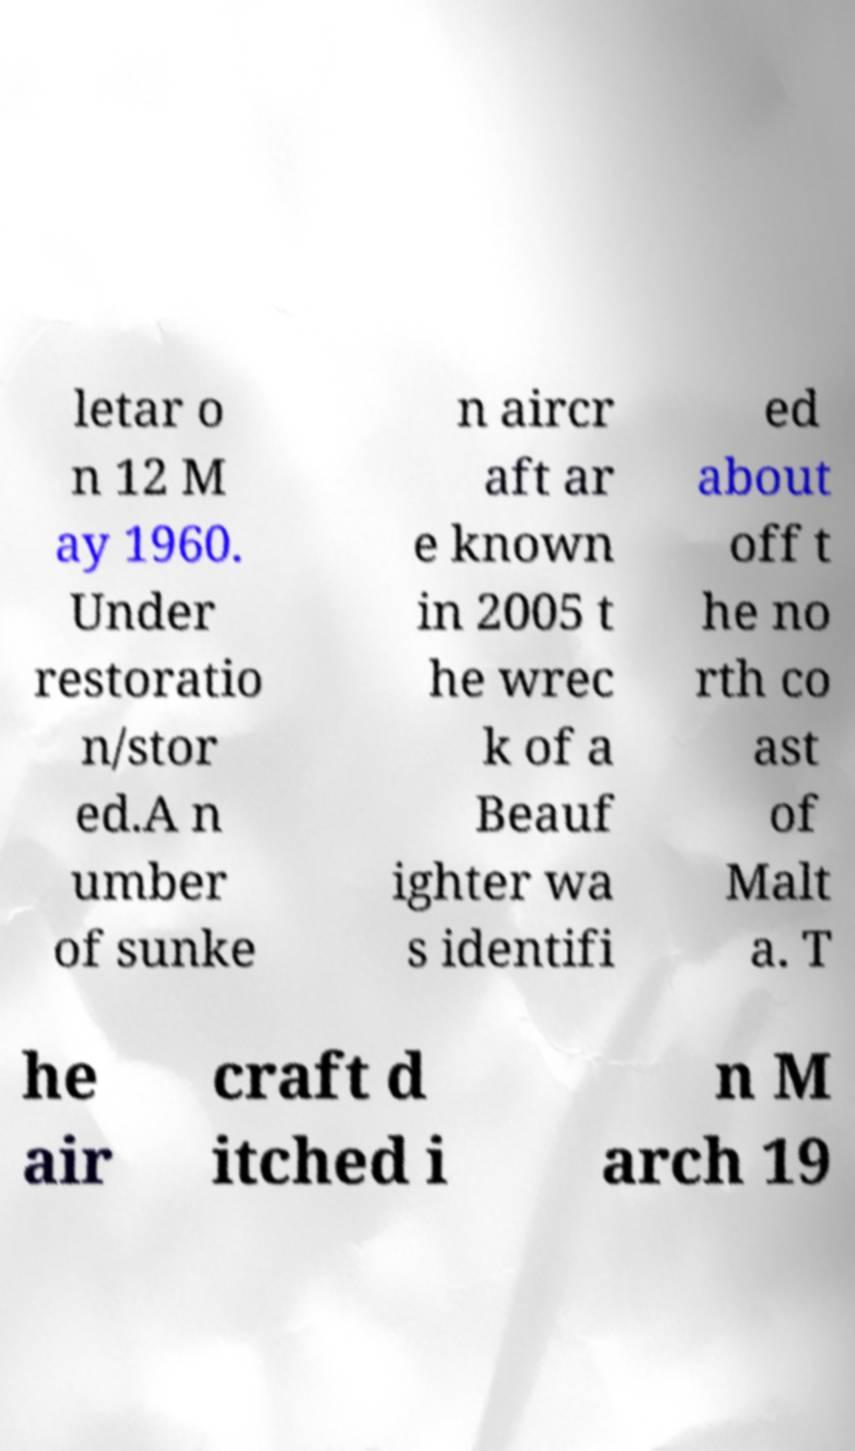I need the written content from this picture converted into text. Can you do that? letar o n 12 M ay 1960. Under restoratio n/stor ed.A n umber of sunke n aircr aft ar e known in 2005 t he wrec k of a Beauf ighter wa s identifi ed about off t he no rth co ast of Malt a. T he air craft d itched i n M arch 19 